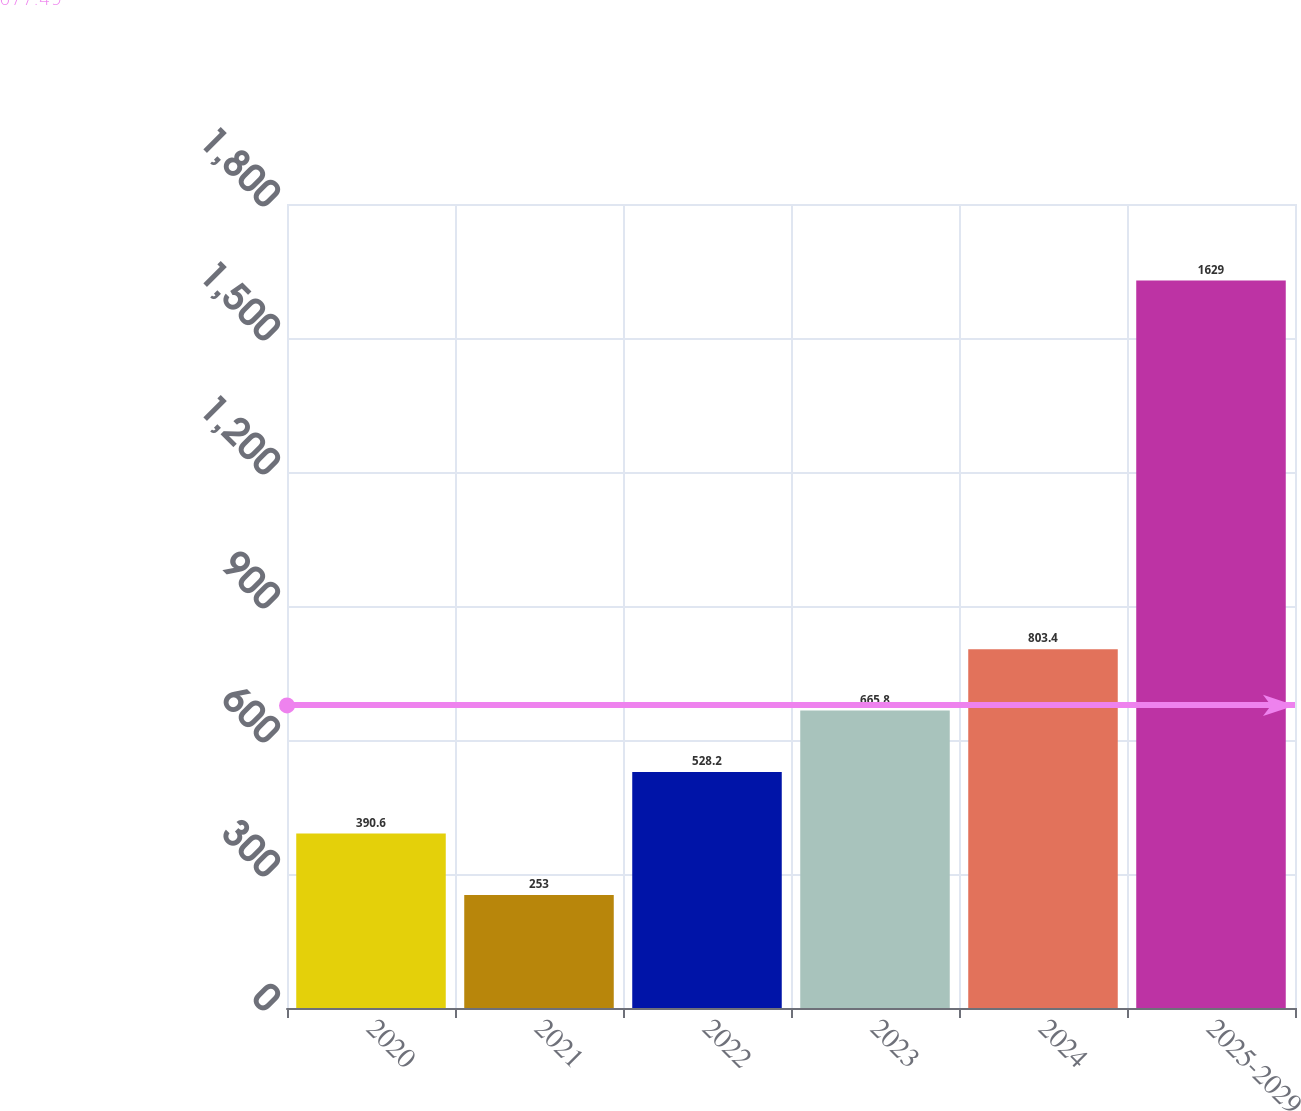<chart> <loc_0><loc_0><loc_500><loc_500><bar_chart><fcel>2020<fcel>2021<fcel>2022<fcel>2023<fcel>2024<fcel>2025-2029<nl><fcel>390.6<fcel>253<fcel>528.2<fcel>665.8<fcel>803.4<fcel>1629<nl></chart> 